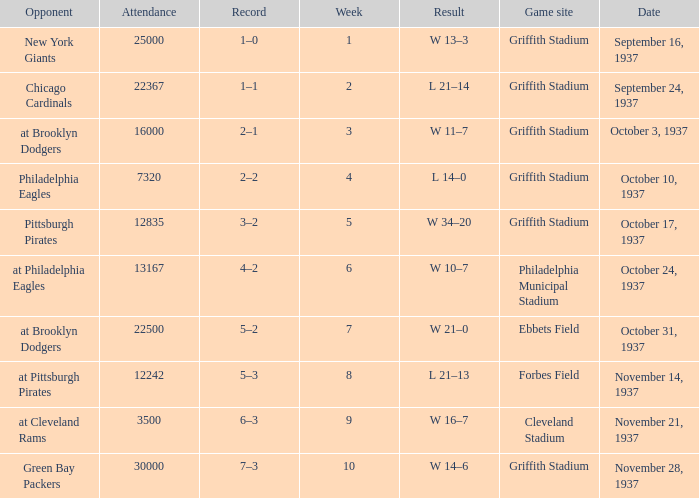On October 17, 1937 what was maximum number or attendants. 12835.0. 